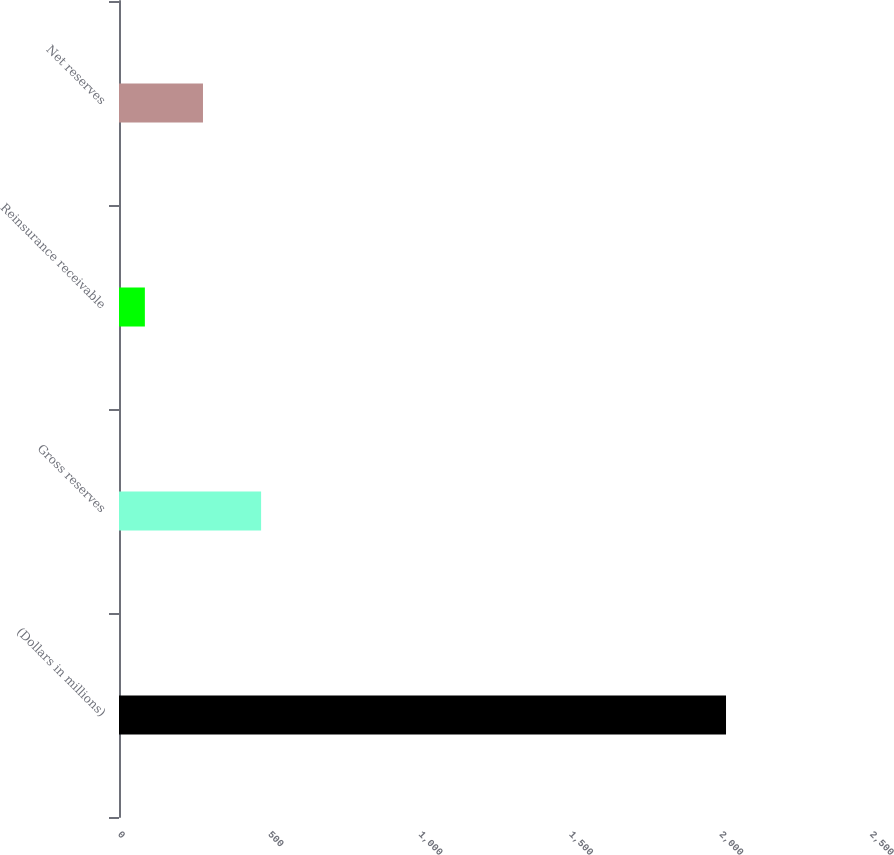Convert chart to OTSL. <chart><loc_0><loc_0><loc_500><loc_500><bar_chart><fcel>(Dollars in millions)<fcel>Gross reserves<fcel>Reinsurance receivable<fcel>Net reserves<nl><fcel>2018<fcel>472.4<fcel>86<fcel>279.2<nl></chart> 